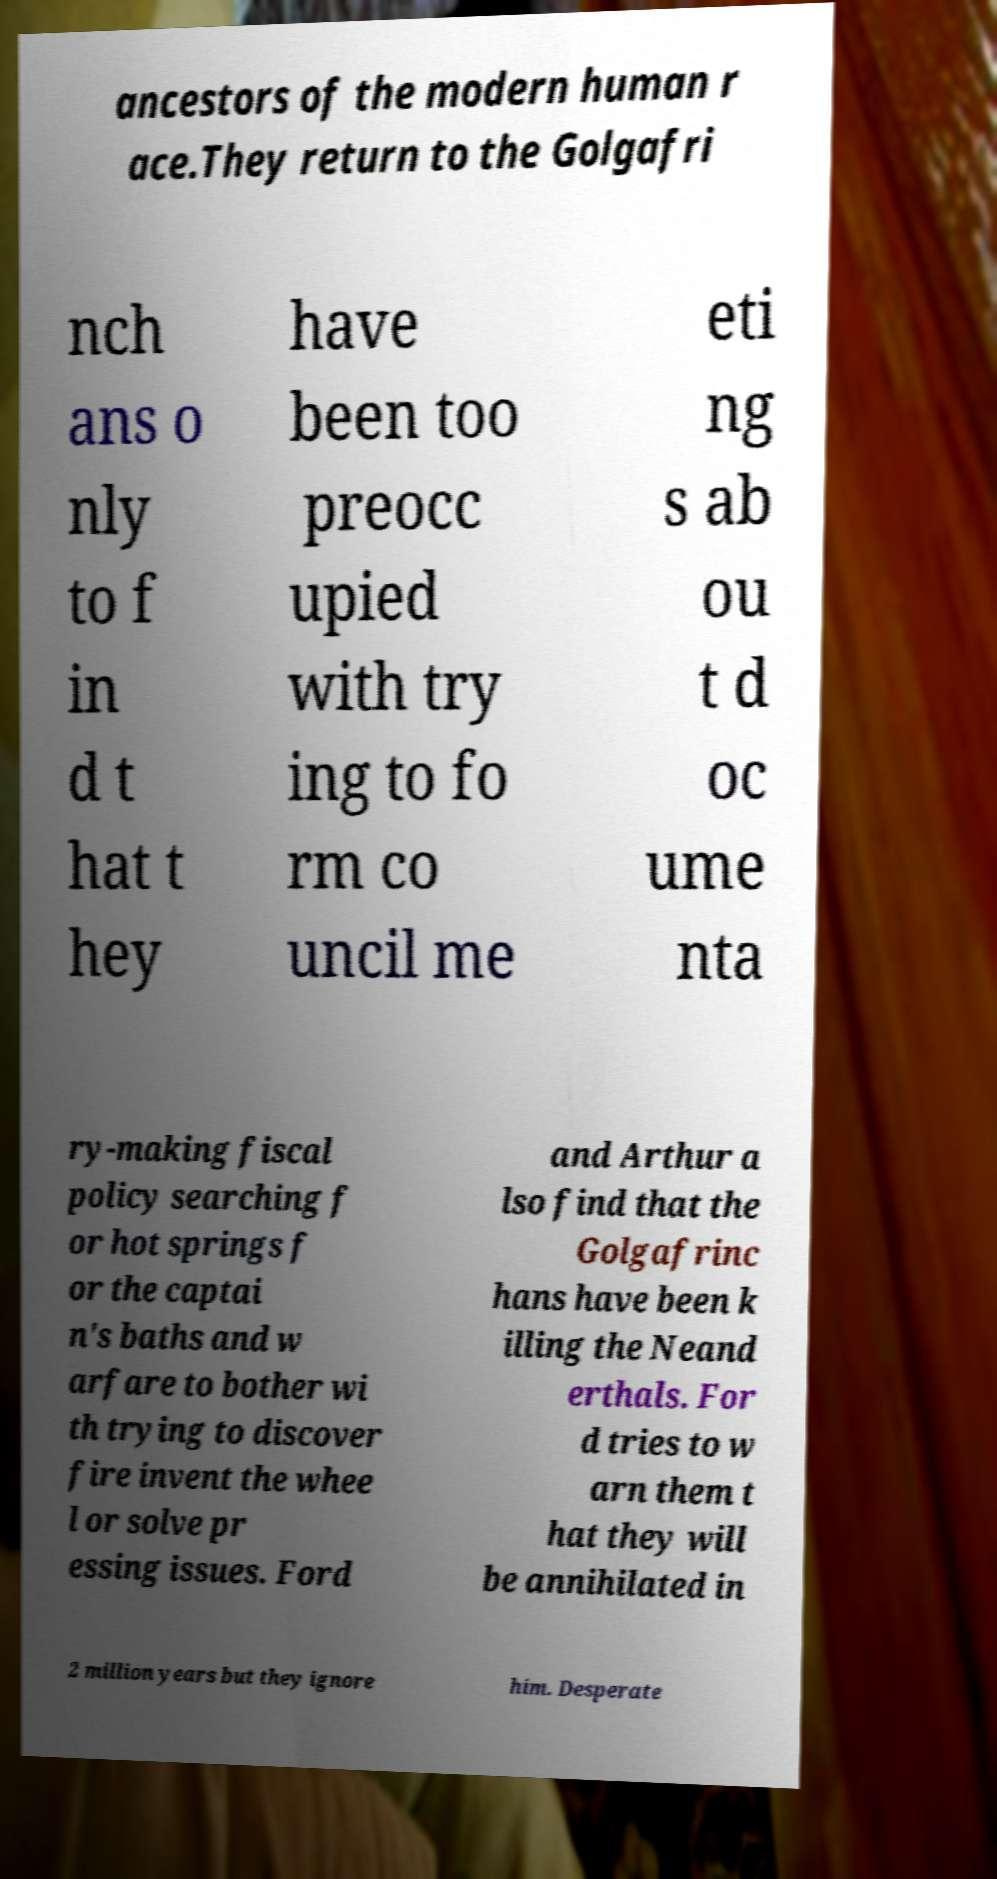There's text embedded in this image that I need extracted. Can you transcribe it verbatim? ancestors of the modern human r ace.They return to the Golgafri nch ans o nly to f in d t hat t hey have been too preocc upied with try ing to fo rm co uncil me eti ng s ab ou t d oc ume nta ry-making fiscal policy searching f or hot springs f or the captai n's baths and w arfare to bother wi th trying to discover fire invent the whee l or solve pr essing issues. Ford and Arthur a lso find that the Golgafrinc hans have been k illing the Neand erthals. For d tries to w arn them t hat they will be annihilated in 2 million years but they ignore him. Desperate 